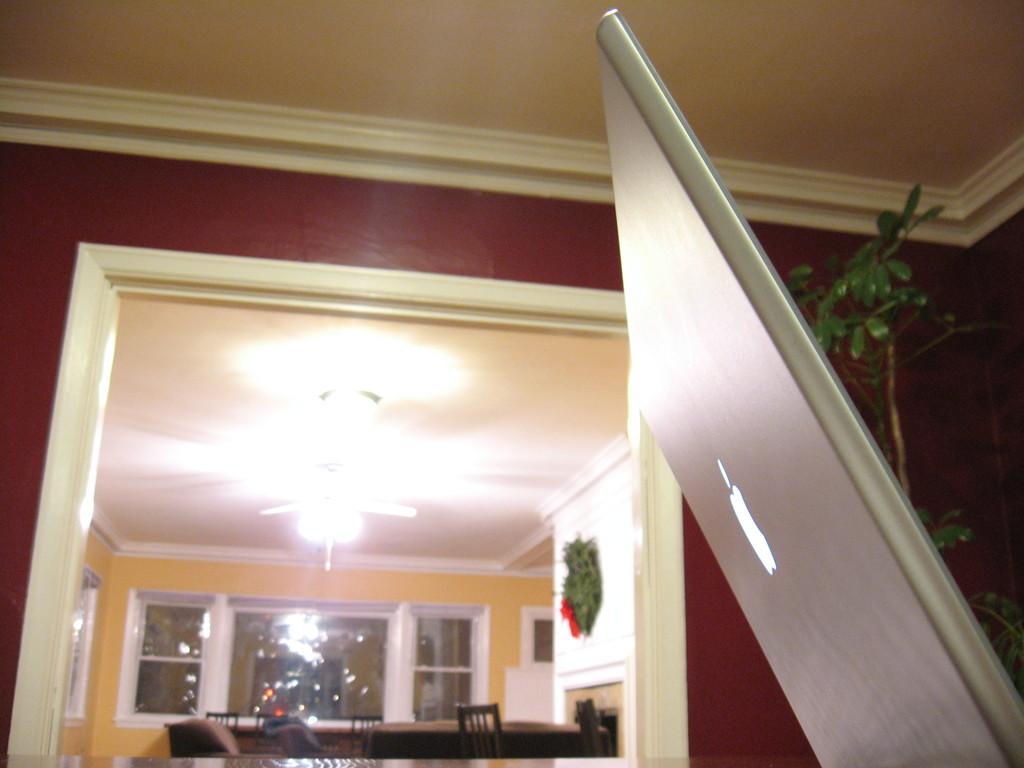In one or two sentences, can you explain what this image depicts? On the right side of the image we can see laptop and tree. In the background we can see door, windows, light, table and chairs. 